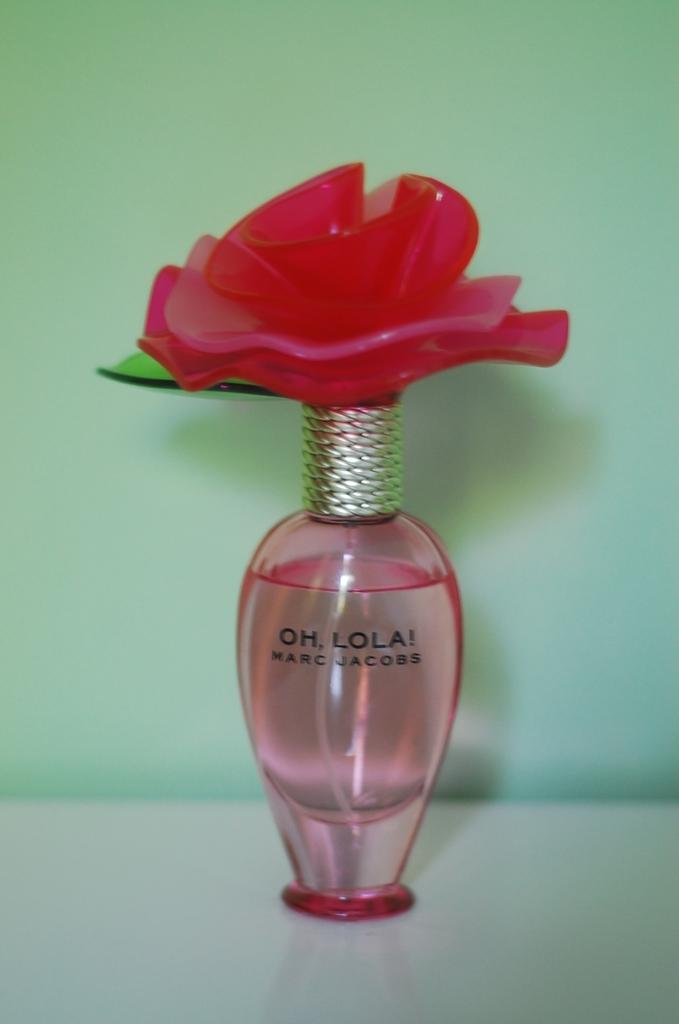<image>
Write a terse but informative summary of the picture. Bottle with a rose on top that is titled "Oh Lola!" by Marc Jacobs. 